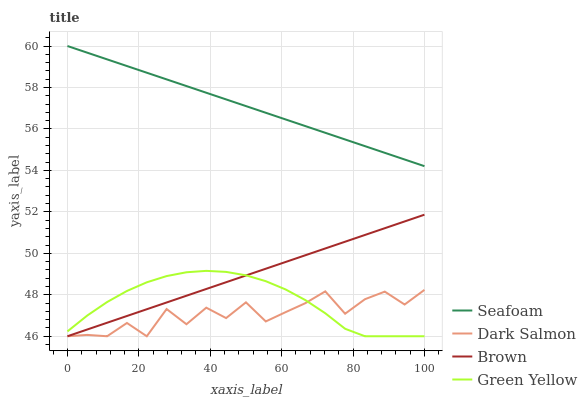Does Dark Salmon have the minimum area under the curve?
Answer yes or no. Yes. Does Seafoam have the maximum area under the curve?
Answer yes or no. Yes. Does Green Yellow have the minimum area under the curve?
Answer yes or no. No. Does Green Yellow have the maximum area under the curve?
Answer yes or no. No. Is Brown the smoothest?
Answer yes or no. Yes. Is Dark Salmon the roughest?
Answer yes or no. Yes. Is Green Yellow the smoothest?
Answer yes or no. No. Is Green Yellow the roughest?
Answer yes or no. No. Does Brown have the lowest value?
Answer yes or no. Yes. Does Seafoam have the lowest value?
Answer yes or no. No. Does Seafoam have the highest value?
Answer yes or no. Yes. Does Green Yellow have the highest value?
Answer yes or no. No. Is Green Yellow less than Seafoam?
Answer yes or no. Yes. Is Seafoam greater than Dark Salmon?
Answer yes or no. Yes. Does Green Yellow intersect Dark Salmon?
Answer yes or no. Yes. Is Green Yellow less than Dark Salmon?
Answer yes or no. No. Is Green Yellow greater than Dark Salmon?
Answer yes or no. No. Does Green Yellow intersect Seafoam?
Answer yes or no. No. 